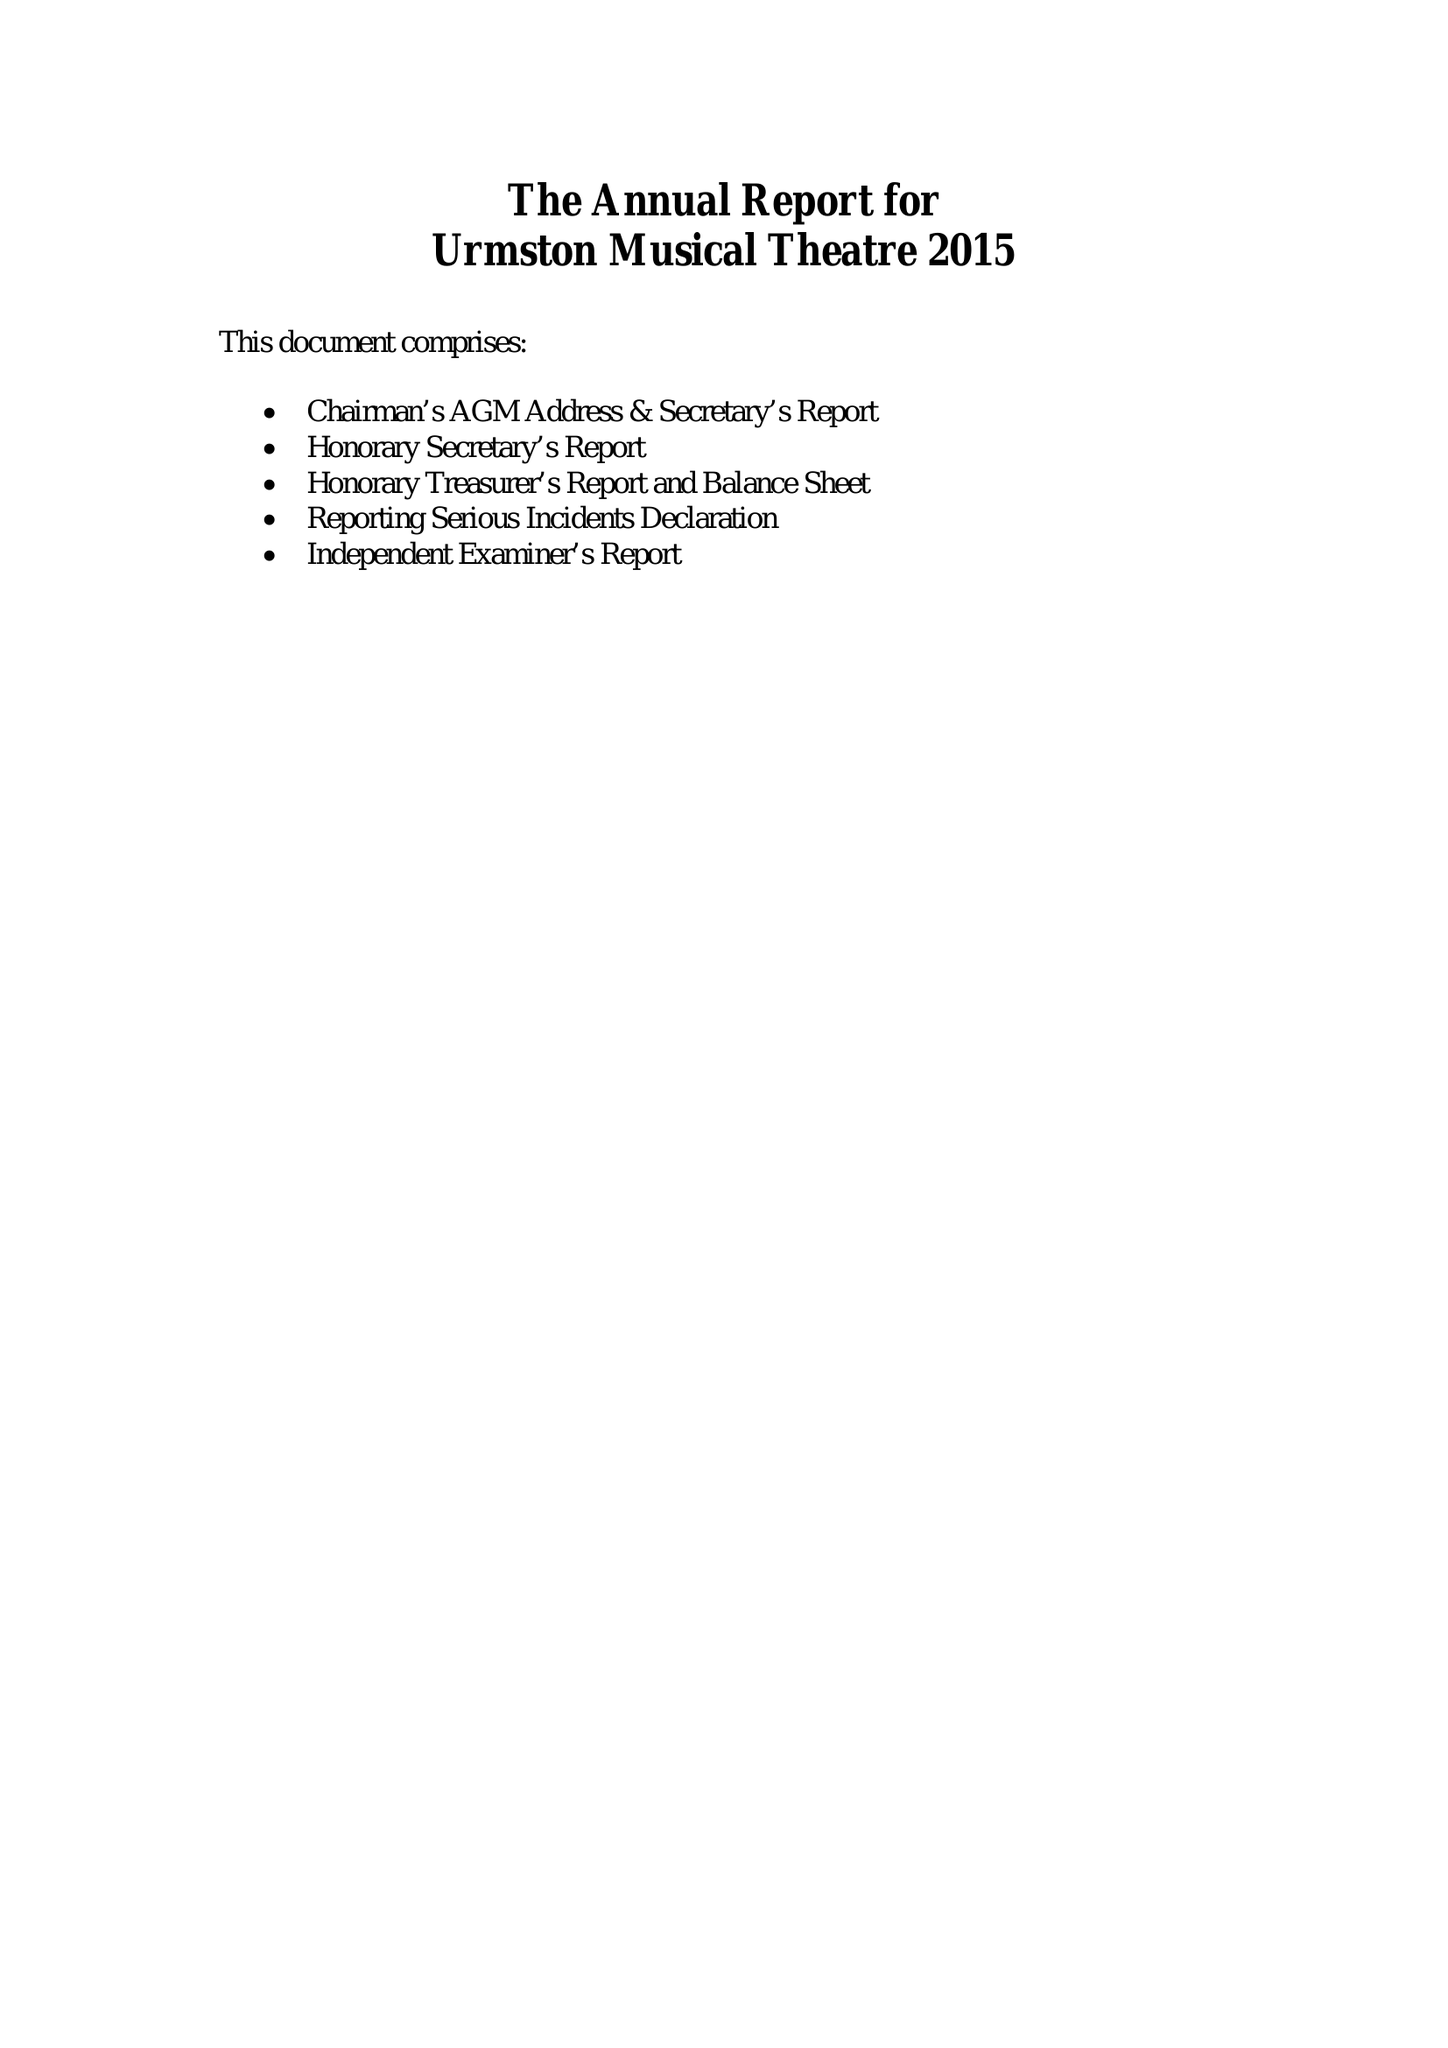What is the value for the report_date?
Answer the question using a single word or phrase. 2015-12-31 